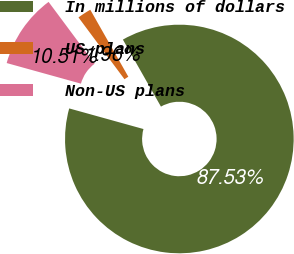<chart> <loc_0><loc_0><loc_500><loc_500><pie_chart><fcel>In millions of dollars<fcel>US plans<fcel>Non-US plans<nl><fcel>87.53%<fcel>1.96%<fcel>10.51%<nl></chart> 